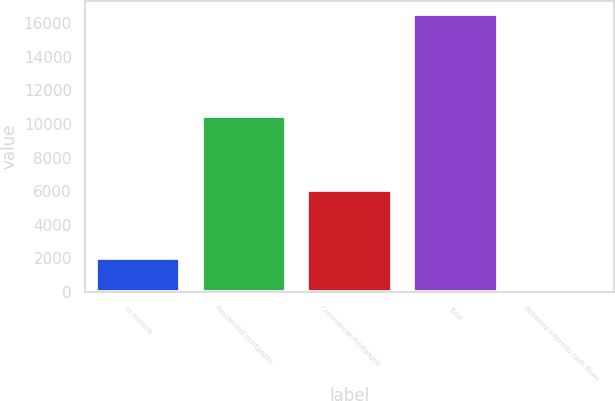Convert chart to OTSL. <chart><loc_0><loc_0><loc_500><loc_500><bar_chart><fcel>in millions<fcel>Residential mortgages<fcel>Commercial mortgages<fcel>Total<fcel>Retained interests cash flows<nl><fcel>2015<fcel>10479<fcel>6043<fcel>16522<fcel>174<nl></chart> 